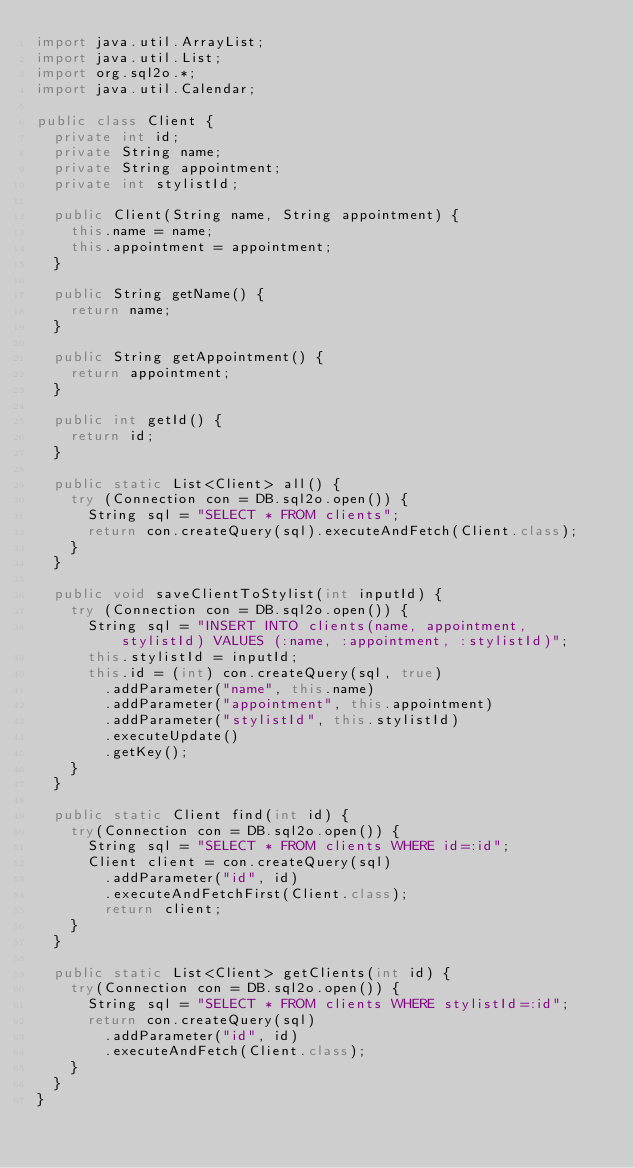Convert code to text. <code><loc_0><loc_0><loc_500><loc_500><_Java_>import java.util.ArrayList;
import java.util.List;
import org.sql2o.*;
import java.util.Calendar;

public class Client {
  private int id;
  private String name;
  private String appointment;
  private int stylistId;

  public Client(String name, String appointment) {
    this.name = name;
    this.appointment = appointment;
  }

  public String getName() {
    return name;
  }

  public String getAppointment() {
    return appointment;
  }

  public int getId() {
    return id;
  }

  public static List<Client> all() {
    try (Connection con = DB.sql2o.open()) {
      String sql = "SELECT * FROM clients";
      return con.createQuery(sql).executeAndFetch(Client.class);
    }
  }

  public void saveClientToStylist(int inputId) {
    try (Connection con = DB.sql2o.open()) {
      String sql = "INSERT INTO clients(name, appointment, stylistId) VALUES (:name, :appointment, :stylistId)";
      this.stylistId = inputId;
      this.id = (int) con.createQuery(sql, true)
        .addParameter("name", this.name)
        .addParameter("appointment", this.appointment)
        .addParameter("stylistId", this.stylistId)
        .executeUpdate()
        .getKey();
    }
  }

  public static Client find(int id) {
    try(Connection con = DB.sql2o.open()) {
      String sql = "SELECT * FROM clients WHERE id=:id";
      Client client = con.createQuery(sql)
        .addParameter("id", id)
        .executeAndFetchFirst(Client.class);
        return client;
    }
  }

  public static List<Client> getClients(int id) {
    try(Connection con = DB.sql2o.open()) {
      String sql = "SELECT * FROM clients WHERE stylistId=:id";
      return con.createQuery(sql)
        .addParameter("id", id)
        .executeAndFetch(Client.class);
    }
  }
}
</code> 